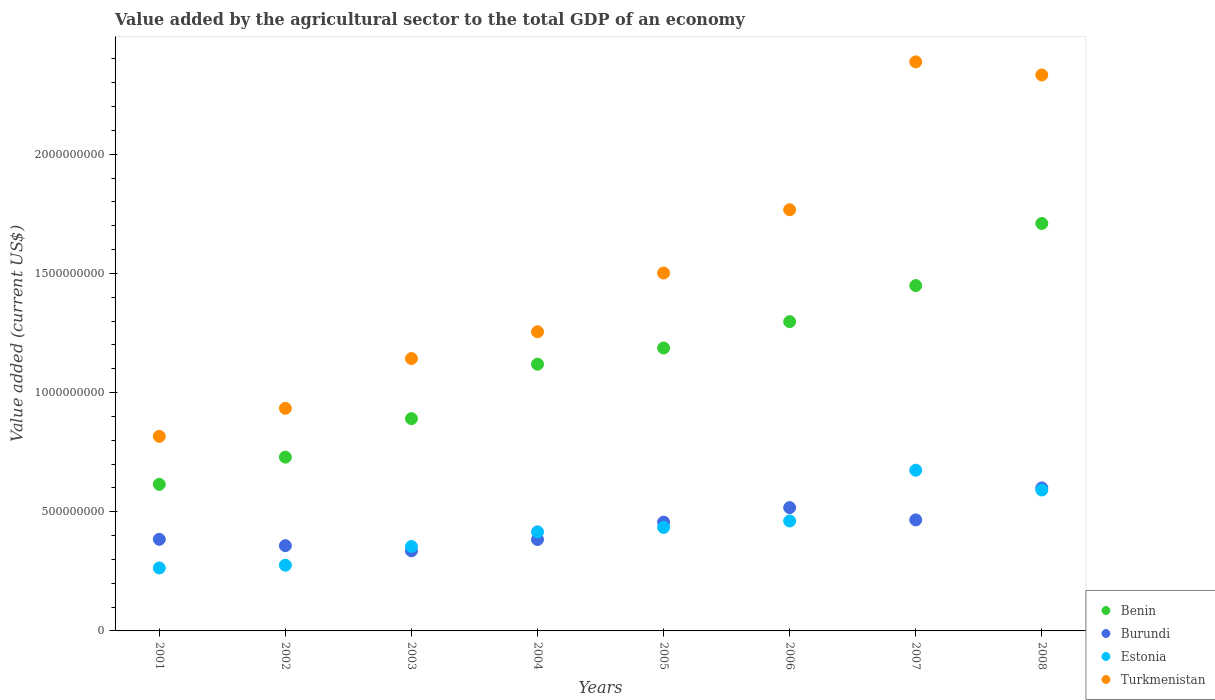Is the number of dotlines equal to the number of legend labels?
Offer a terse response. Yes. What is the value added by the agricultural sector to the total GDP in Turkmenistan in 2005?
Offer a terse response. 1.50e+09. Across all years, what is the maximum value added by the agricultural sector to the total GDP in Benin?
Keep it short and to the point. 1.71e+09. Across all years, what is the minimum value added by the agricultural sector to the total GDP in Benin?
Make the answer very short. 6.15e+08. In which year was the value added by the agricultural sector to the total GDP in Burundi minimum?
Ensure brevity in your answer.  2003. What is the total value added by the agricultural sector to the total GDP in Burundi in the graph?
Ensure brevity in your answer.  3.50e+09. What is the difference between the value added by the agricultural sector to the total GDP in Turkmenistan in 2002 and that in 2005?
Keep it short and to the point. -5.68e+08. What is the difference between the value added by the agricultural sector to the total GDP in Estonia in 2006 and the value added by the agricultural sector to the total GDP in Burundi in 2005?
Your answer should be compact. 4.91e+06. What is the average value added by the agricultural sector to the total GDP in Burundi per year?
Make the answer very short. 4.38e+08. In the year 2007, what is the difference between the value added by the agricultural sector to the total GDP in Turkmenistan and value added by the agricultural sector to the total GDP in Estonia?
Offer a very short reply. 1.71e+09. In how many years, is the value added by the agricultural sector to the total GDP in Turkmenistan greater than 2300000000 US$?
Your answer should be very brief. 2. What is the ratio of the value added by the agricultural sector to the total GDP in Benin in 2006 to that in 2007?
Provide a short and direct response. 0.9. Is the value added by the agricultural sector to the total GDP in Burundi in 2006 less than that in 2008?
Your answer should be very brief. Yes. Is the difference between the value added by the agricultural sector to the total GDP in Turkmenistan in 2005 and 2008 greater than the difference between the value added by the agricultural sector to the total GDP in Estonia in 2005 and 2008?
Offer a very short reply. No. What is the difference between the highest and the second highest value added by the agricultural sector to the total GDP in Benin?
Your answer should be compact. 2.61e+08. What is the difference between the highest and the lowest value added by the agricultural sector to the total GDP in Benin?
Your answer should be compact. 1.09e+09. In how many years, is the value added by the agricultural sector to the total GDP in Burundi greater than the average value added by the agricultural sector to the total GDP in Burundi taken over all years?
Your response must be concise. 4. Is the sum of the value added by the agricultural sector to the total GDP in Turkmenistan in 2001 and 2002 greater than the maximum value added by the agricultural sector to the total GDP in Benin across all years?
Provide a succinct answer. Yes. Is it the case that in every year, the sum of the value added by the agricultural sector to the total GDP in Estonia and value added by the agricultural sector to the total GDP in Benin  is greater than the sum of value added by the agricultural sector to the total GDP in Turkmenistan and value added by the agricultural sector to the total GDP in Burundi?
Ensure brevity in your answer.  No. Is the value added by the agricultural sector to the total GDP in Benin strictly less than the value added by the agricultural sector to the total GDP in Turkmenistan over the years?
Offer a very short reply. Yes. How many dotlines are there?
Your response must be concise. 4. How many years are there in the graph?
Give a very brief answer. 8. What is the difference between two consecutive major ticks on the Y-axis?
Make the answer very short. 5.00e+08. Are the values on the major ticks of Y-axis written in scientific E-notation?
Your answer should be compact. No. Does the graph contain any zero values?
Provide a short and direct response. No. How many legend labels are there?
Offer a very short reply. 4. How are the legend labels stacked?
Your answer should be very brief. Vertical. What is the title of the graph?
Ensure brevity in your answer.  Value added by the agricultural sector to the total GDP of an economy. Does "Denmark" appear as one of the legend labels in the graph?
Make the answer very short. No. What is the label or title of the Y-axis?
Make the answer very short. Value added (current US$). What is the Value added (current US$) in Benin in 2001?
Your answer should be compact. 6.15e+08. What is the Value added (current US$) in Burundi in 2001?
Your response must be concise. 3.84e+08. What is the Value added (current US$) in Estonia in 2001?
Provide a short and direct response. 2.64e+08. What is the Value added (current US$) in Turkmenistan in 2001?
Provide a succinct answer. 8.16e+08. What is the Value added (current US$) in Benin in 2002?
Offer a terse response. 7.29e+08. What is the Value added (current US$) in Burundi in 2002?
Provide a short and direct response. 3.58e+08. What is the Value added (current US$) in Estonia in 2002?
Offer a very short reply. 2.76e+08. What is the Value added (current US$) of Turkmenistan in 2002?
Offer a very short reply. 9.34e+08. What is the Value added (current US$) of Benin in 2003?
Your response must be concise. 8.91e+08. What is the Value added (current US$) of Burundi in 2003?
Provide a succinct answer. 3.36e+08. What is the Value added (current US$) in Estonia in 2003?
Your answer should be compact. 3.54e+08. What is the Value added (current US$) of Turkmenistan in 2003?
Give a very brief answer. 1.14e+09. What is the Value added (current US$) of Benin in 2004?
Offer a very short reply. 1.12e+09. What is the Value added (current US$) of Burundi in 2004?
Provide a succinct answer. 3.84e+08. What is the Value added (current US$) of Estonia in 2004?
Your answer should be compact. 4.16e+08. What is the Value added (current US$) in Turkmenistan in 2004?
Make the answer very short. 1.26e+09. What is the Value added (current US$) in Benin in 2005?
Offer a very short reply. 1.19e+09. What is the Value added (current US$) in Burundi in 2005?
Your answer should be very brief. 4.56e+08. What is the Value added (current US$) of Estonia in 2005?
Make the answer very short. 4.34e+08. What is the Value added (current US$) in Turkmenistan in 2005?
Ensure brevity in your answer.  1.50e+09. What is the Value added (current US$) of Benin in 2006?
Your answer should be very brief. 1.30e+09. What is the Value added (current US$) in Burundi in 2006?
Offer a terse response. 5.17e+08. What is the Value added (current US$) of Estonia in 2006?
Make the answer very short. 4.61e+08. What is the Value added (current US$) in Turkmenistan in 2006?
Give a very brief answer. 1.77e+09. What is the Value added (current US$) of Benin in 2007?
Ensure brevity in your answer.  1.45e+09. What is the Value added (current US$) of Burundi in 2007?
Keep it short and to the point. 4.66e+08. What is the Value added (current US$) of Estonia in 2007?
Offer a very short reply. 6.74e+08. What is the Value added (current US$) in Turkmenistan in 2007?
Provide a short and direct response. 2.39e+09. What is the Value added (current US$) of Benin in 2008?
Provide a succinct answer. 1.71e+09. What is the Value added (current US$) of Burundi in 2008?
Your answer should be very brief. 6.00e+08. What is the Value added (current US$) of Estonia in 2008?
Your response must be concise. 5.91e+08. What is the Value added (current US$) of Turkmenistan in 2008?
Offer a terse response. 2.33e+09. Across all years, what is the maximum Value added (current US$) of Benin?
Offer a very short reply. 1.71e+09. Across all years, what is the maximum Value added (current US$) of Burundi?
Provide a succinct answer. 6.00e+08. Across all years, what is the maximum Value added (current US$) in Estonia?
Provide a succinct answer. 6.74e+08. Across all years, what is the maximum Value added (current US$) of Turkmenistan?
Offer a very short reply. 2.39e+09. Across all years, what is the minimum Value added (current US$) in Benin?
Your response must be concise. 6.15e+08. Across all years, what is the minimum Value added (current US$) in Burundi?
Provide a succinct answer. 3.36e+08. Across all years, what is the minimum Value added (current US$) of Estonia?
Ensure brevity in your answer.  2.64e+08. Across all years, what is the minimum Value added (current US$) in Turkmenistan?
Offer a very short reply. 8.16e+08. What is the total Value added (current US$) of Benin in the graph?
Make the answer very short. 9.00e+09. What is the total Value added (current US$) in Burundi in the graph?
Your response must be concise. 3.50e+09. What is the total Value added (current US$) of Estonia in the graph?
Keep it short and to the point. 3.47e+09. What is the total Value added (current US$) in Turkmenistan in the graph?
Keep it short and to the point. 1.21e+1. What is the difference between the Value added (current US$) of Benin in 2001 and that in 2002?
Provide a short and direct response. -1.14e+08. What is the difference between the Value added (current US$) in Burundi in 2001 and that in 2002?
Keep it short and to the point. 2.67e+07. What is the difference between the Value added (current US$) of Estonia in 2001 and that in 2002?
Keep it short and to the point. -1.17e+07. What is the difference between the Value added (current US$) of Turkmenistan in 2001 and that in 2002?
Your answer should be compact. -1.18e+08. What is the difference between the Value added (current US$) of Benin in 2001 and that in 2003?
Make the answer very short. -2.76e+08. What is the difference between the Value added (current US$) in Burundi in 2001 and that in 2003?
Your answer should be compact. 4.83e+07. What is the difference between the Value added (current US$) in Estonia in 2001 and that in 2003?
Offer a terse response. -9.02e+07. What is the difference between the Value added (current US$) of Turkmenistan in 2001 and that in 2003?
Provide a succinct answer. -3.26e+08. What is the difference between the Value added (current US$) in Benin in 2001 and that in 2004?
Your answer should be very brief. -5.04e+08. What is the difference between the Value added (current US$) of Burundi in 2001 and that in 2004?
Offer a very short reply. 8.98e+05. What is the difference between the Value added (current US$) of Estonia in 2001 and that in 2004?
Keep it short and to the point. -1.52e+08. What is the difference between the Value added (current US$) in Turkmenistan in 2001 and that in 2004?
Give a very brief answer. -4.39e+08. What is the difference between the Value added (current US$) of Benin in 2001 and that in 2005?
Your response must be concise. -5.72e+08. What is the difference between the Value added (current US$) in Burundi in 2001 and that in 2005?
Your answer should be compact. -7.20e+07. What is the difference between the Value added (current US$) in Estonia in 2001 and that in 2005?
Keep it short and to the point. -1.70e+08. What is the difference between the Value added (current US$) of Turkmenistan in 2001 and that in 2005?
Offer a very short reply. -6.85e+08. What is the difference between the Value added (current US$) of Benin in 2001 and that in 2006?
Your response must be concise. -6.83e+08. What is the difference between the Value added (current US$) in Burundi in 2001 and that in 2006?
Ensure brevity in your answer.  -1.33e+08. What is the difference between the Value added (current US$) in Estonia in 2001 and that in 2006?
Ensure brevity in your answer.  -1.97e+08. What is the difference between the Value added (current US$) in Turkmenistan in 2001 and that in 2006?
Give a very brief answer. -9.51e+08. What is the difference between the Value added (current US$) of Benin in 2001 and that in 2007?
Offer a very short reply. -8.34e+08. What is the difference between the Value added (current US$) of Burundi in 2001 and that in 2007?
Your answer should be very brief. -8.14e+07. What is the difference between the Value added (current US$) in Estonia in 2001 and that in 2007?
Provide a short and direct response. -4.10e+08. What is the difference between the Value added (current US$) in Turkmenistan in 2001 and that in 2007?
Your answer should be compact. -1.57e+09. What is the difference between the Value added (current US$) of Benin in 2001 and that in 2008?
Your answer should be compact. -1.09e+09. What is the difference between the Value added (current US$) of Burundi in 2001 and that in 2008?
Offer a very short reply. -2.16e+08. What is the difference between the Value added (current US$) in Estonia in 2001 and that in 2008?
Provide a short and direct response. -3.27e+08. What is the difference between the Value added (current US$) in Turkmenistan in 2001 and that in 2008?
Provide a succinct answer. -1.52e+09. What is the difference between the Value added (current US$) of Benin in 2002 and that in 2003?
Offer a very short reply. -1.62e+08. What is the difference between the Value added (current US$) of Burundi in 2002 and that in 2003?
Give a very brief answer. 2.15e+07. What is the difference between the Value added (current US$) of Estonia in 2002 and that in 2003?
Your answer should be very brief. -7.86e+07. What is the difference between the Value added (current US$) of Turkmenistan in 2002 and that in 2003?
Your answer should be compact. -2.09e+08. What is the difference between the Value added (current US$) in Benin in 2002 and that in 2004?
Give a very brief answer. -3.90e+08. What is the difference between the Value added (current US$) in Burundi in 2002 and that in 2004?
Your answer should be very brief. -2.58e+07. What is the difference between the Value added (current US$) of Estonia in 2002 and that in 2004?
Make the answer very short. -1.40e+08. What is the difference between the Value added (current US$) of Turkmenistan in 2002 and that in 2004?
Your answer should be compact. -3.21e+08. What is the difference between the Value added (current US$) in Benin in 2002 and that in 2005?
Offer a very short reply. -4.58e+08. What is the difference between the Value added (current US$) in Burundi in 2002 and that in 2005?
Your answer should be very brief. -9.87e+07. What is the difference between the Value added (current US$) of Estonia in 2002 and that in 2005?
Offer a very short reply. -1.58e+08. What is the difference between the Value added (current US$) in Turkmenistan in 2002 and that in 2005?
Provide a succinct answer. -5.68e+08. What is the difference between the Value added (current US$) in Benin in 2002 and that in 2006?
Your answer should be very brief. -5.69e+08. What is the difference between the Value added (current US$) in Burundi in 2002 and that in 2006?
Ensure brevity in your answer.  -1.60e+08. What is the difference between the Value added (current US$) in Estonia in 2002 and that in 2006?
Your response must be concise. -1.86e+08. What is the difference between the Value added (current US$) of Turkmenistan in 2002 and that in 2006?
Provide a short and direct response. -8.33e+08. What is the difference between the Value added (current US$) of Benin in 2002 and that in 2007?
Offer a very short reply. -7.20e+08. What is the difference between the Value added (current US$) in Burundi in 2002 and that in 2007?
Offer a very short reply. -1.08e+08. What is the difference between the Value added (current US$) of Estonia in 2002 and that in 2007?
Provide a succinct answer. -3.99e+08. What is the difference between the Value added (current US$) in Turkmenistan in 2002 and that in 2007?
Ensure brevity in your answer.  -1.45e+09. What is the difference between the Value added (current US$) in Benin in 2002 and that in 2008?
Give a very brief answer. -9.81e+08. What is the difference between the Value added (current US$) of Burundi in 2002 and that in 2008?
Your answer should be compact. -2.42e+08. What is the difference between the Value added (current US$) of Estonia in 2002 and that in 2008?
Offer a terse response. -3.16e+08. What is the difference between the Value added (current US$) of Turkmenistan in 2002 and that in 2008?
Offer a terse response. -1.40e+09. What is the difference between the Value added (current US$) of Benin in 2003 and that in 2004?
Your response must be concise. -2.29e+08. What is the difference between the Value added (current US$) of Burundi in 2003 and that in 2004?
Offer a terse response. -4.74e+07. What is the difference between the Value added (current US$) of Estonia in 2003 and that in 2004?
Ensure brevity in your answer.  -6.14e+07. What is the difference between the Value added (current US$) in Turkmenistan in 2003 and that in 2004?
Make the answer very short. -1.12e+08. What is the difference between the Value added (current US$) of Benin in 2003 and that in 2005?
Your answer should be compact. -2.96e+08. What is the difference between the Value added (current US$) of Burundi in 2003 and that in 2005?
Make the answer very short. -1.20e+08. What is the difference between the Value added (current US$) of Estonia in 2003 and that in 2005?
Offer a very short reply. -7.99e+07. What is the difference between the Value added (current US$) in Turkmenistan in 2003 and that in 2005?
Ensure brevity in your answer.  -3.59e+08. What is the difference between the Value added (current US$) in Benin in 2003 and that in 2006?
Ensure brevity in your answer.  -4.07e+08. What is the difference between the Value added (current US$) in Burundi in 2003 and that in 2006?
Make the answer very short. -1.81e+08. What is the difference between the Value added (current US$) in Estonia in 2003 and that in 2006?
Give a very brief answer. -1.07e+08. What is the difference between the Value added (current US$) of Turkmenistan in 2003 and that in 2006?
Make the answer very short. -6.25e+08. What is the difference between the Value added (current US$) of Benin in 2003 and that in 2007?
Ensure brevity in your answer.  -5.58e+08. What is the difference between the Value added (current US$) of Burundi in 2003 and that in 2007?
Provide a succinct answer. -1.30e+08. What is the difference between the Value added (current US$) in Estonia in 2003 and that in 2007?
Provide a succinct answer. -3.20e+08. What is the difference between the Value added (current US$) of Turkmenistan in 2003 and that in 2007?
Your response must be concise. -1.24e+09. What is the difference between the Value added (current US$) of Benin in 2003 and that in 2008?
Give a very brief answer. -8.19e+08. What is the difference between the Value added (current US$) of Burundi in 2003 and that in 2008?
Your answer should be compact. -2.64e+08. What is the difference between the Value added (current US$) in Estonia in 2003 and that in 2008?
Keep it short and to the point. -2.37e+08. What is the difference between the Value added (current US$) of Turkmenistan in 2003 and that in 2008?
Make the answer very short. -1.19e+09. What is the difference between the Value added (current US$) in Benin in 2004 and that in 2005?
Give a very brief answer. -6.79e+07. What is the difference between the Value added (current US$) of Burundi in 2004 and that in 2005?
Make the answer very short. -7.29e+07. What is the difference between the Value added (current US$) of Estonia in 2004 and that in 2005?
Offer a terse response. -1.85e+07. What is the difference between the Value added (current US$) of Turkmenistan in 2004 and that in 2005?
Keep it short and to the point. -2.47e+08. What is the difference between the Value added (current US$) of Benin in 2004 and that in 2006?
Your answer should be compact. -1.79e+08. What is the difference between the Value added (current US$) of Burundi in 2004 and that in 2006?
Provide a succinct answer. -1.34e+08. What is the difference between the Value added (current US$) in Estonia in 2004 and that in 2006?
Give a very brief answer. -4.56e+07. What is the difference between the Value added (current US$) of Turkmenistan in 2004 and that in 2006?
Provide a succinct answer. -5.12e+08. What is the difference between the Value added (current US$) in Benin in 2004 and that in 2007?
Keep it short and to the point. -3.30e+08. What is the difference between the Value added (current US$) of Burundi in 2004 and that in 2007?
Your answer should be compact. -8.23e+07. What is the difference between the Value added (current US$) in Estonia in 2004 and that in 2007?
Keep it short and to the point. -2.59e+08. What is the difference between the Value added (current US$) of Turkmenistan in 2004 and that in 2007?
Ensure brevity in your answer.  -1.13e+09. What is the difference between the Value added (current US$) of Benin in 2004 and that in 2008?
Keep it short and to the point. -5.90e+08. What is the difference between the Value added (current US$) of Burundi in 2004 and that in 2008?
Your response must be concise. -2.17e+08. What is the difference between the Value added (current US$) of Estonia in 2004 and that in 2008?
Make the answer very short. -1.76e+08. What is the difference between the Value added (current US$) in Turkmenistan in 2004 and that in 2008?
Provide a succinct answer. -1.08e+09. What is the difference between the Value added (current US$) of Benin in 2005 and that in 2006?
Provide a succinct answer. -1.11e+08. What is the difference between the Value added (current US$) in Burundi in 2005 and that in 2006?
Provide a short and direct response. -6.11e+07. What is the difference between the Value added (current US$) in Estonia in 2005 and that in 2006?
Your response must be concise. -2.70e+07. What is the difference between the Value added (current US$) of Turkmenistan in 2005 and that in 2006?
Ensure brevity in your answer.  -2.66e+08. What is the difference between the Value added (current US$) of Benin in 2005 and that in 2007?
Provide a succinct answer. -2.62e+08. What is the difference between the Value added (current US$) of Burundi in 2005 and that in 2007?
Your response must be concise. -9.49e+06. What is the difference between the Value added (current US$) of Estonia in 2005 and that in 2007?
Give a very brief answer. -2.40e+08. What is the difference between the Value added (current US$) of Turkmenistan in 2005 and that in 2007?
Provide a short and direct response. -8.86e+08. What is the difference between the Value added (current US$) of Benin in 2005 and that in 2008?
Offer a very short reply. -5.22e+08. What is the difference between the Value added (current US$) in Burundi in 2005 and that in 2008?
Offer a very short reply. -1.44e+08. What is the difference between the Value added (current US$) in Estonia in 2005 and that in 2008?
Offer a very short reply. -1.57e+08. What is the difference between the Value added (current US$) of Turkmenistan in 2005 and that in 2008?
Your answer should be very brief. -8.31e+08. What is the difference between the Value added (current US$) in Benin in 2006 and that in 2007?
Give a very brief answer. -1.51e+08. What is the difference between the Value added (current US$) in Burundi in 2006 and that in 2007?
Your response must be concise. 5.16e+07. What is the difference between the Value added (current US$) in Estonia in 2006 and that in 2007?
Give a very brief answer. -2.13e+08. What is the difference between the Value added (current US$) in Turkmenistan in 2006 and that in 2007?
Your answer should be compact. -6.20e+08. What is the difference between the Value added (current US$) of Benin in 2006 and that in 2008?
Your answer should be compact. -4.12e+08. What is the difference between the Value added (current US$) in Burundi in 2006 and that in 2008?
Your answer should be compact. -8.27e+07. What is the difference between the Value added (current US$) in Estonia in 2006 and that in 2008?
Provide a succinct answer. -1.30e+08. What is the difference between the Value added (current US$) of Turkmenistan in 2006 and that in 2008?
Offer a terse response. -5.66e+08. What is the difference between the Value added (current US$) of Benin in 2007 and that in 2008?
Offer a terse response. -2.61e+08. What is the difference between the Value added (current US$) of Burundi in 2007 and that in 2008?
Offer a very short reply. -1.34e+08. What is the difference between the Value added (current US$) in Estonia in 2007 and that in 2008?
Your answer should be very brief. 8.30e+07. What is the difference between the Value added (current US$) in Turkmenistan in 2007 and that in 2008?
Provide a succinct answer. 5.48e+07. What is the difference between the Value added (current US$) in Benin in 2001 and the Value added (current US$) in Burundi in 2002?
Offer a terse response. 2.57e+08. What is the difference between the Value added (current US$) of Benin in 2001 and the Value added (current US$) of Estonia in 2002?
Ensure brevity in your answer.  3.39e+08. What is the difference between the Value added (current US$) in Benin in 2001 and the Value added (current US$) in Turkmenistan in 2002?
Your response must be concise. -3.19e+08. What is the difference between the Value added (current US$) in Burundi in 2001 and the Value added (current US$) in Estonia in 2002?
Offer a very short reply. 1.09e+08. What is the difference between the Value added (current US$) in Burundi in 2001 and the Value added (current US$) in Turkmenistan in 2002?
Offer a terse response. -5.50e+08. What is the difference between the Value added (current US$) in Estonia in 2001 and the Value added (current US$) in Turkmenistan in 2002?
Provide a succinct answer. -6.70e+08. What is the difference between the Value added (current US$) in Benin in 2001 and the Value added (current US$) in Burundi in 2003?
Make the answer very short. 2.79e+08. What is the difference between the Value added (current US$) in Benin in 2001 and the Value added (current US$) in Estonia in 2003?
Your response must be concise. 2.61e+08. What is the difference between the Value added (current US$) in Benin in 2001 and the Value added (current US$) in Turkmenistan in 2003?
Your response must be concise. -5.28e+08. What is the difference between the Value added (current US$) in Burundi in 2001 and the Value added (current US$) in Estonia in 2003?
Your response must be concise. 3.00e+07. What is the difference between the Value added (current US$) of Burundi in 2001 and the Value added (current US$) of Turkmenistan in 2003?
Give a very brief answer. -7.58e+08. What is the difference between the Value added (current US$) in Estonia in 2001 and the Value added (current US$) in Turkmenistan in 2003?
Your answer should be compact. -8.79e+08. What is the difference between the Value added (current US$) of Benin in 2001 and the Value added (current US$) of Burundi in 2004?
Your response must be concise. 2.32e+08. What is the difference between the Value added (current US$) in Benin in 2001 and the Value added (current US$) in Estonia in 2004?
Make the answer very short. 1.99e+08. What is the difference between the Value added (current US$) of Benin in 2001 and the Value added (current US$) of Turkmenistan in 2004?
Keep it short and to the point. -6.40e+08. What is the difference between the Value added (current US$) in Burundi in 2001 and the Value added (current US$) in Estonia in 2004?
Offer a terse response. -3.13e+07. What is the difference between the Value added (current US$) of Burundi in 2001 and the Value added (current US$) of Turkmenistan in 2004?
Your answer should be compact. -8.71e+08. What is the difference between the Value added (current US$) of Estonia in 2001 and the Value added (current US$) of Turkmenistan in 2004?
Ensure brevity in your answer.  -9.91e+08. What is the difference between the Value added (current US$) in Benin in 2001 and the Value added (current US$) in Burundi in 2005?
Ensure brevity in your answer.  1.59e+08. What is the difference between the Value added (current US$) in Benin in 2001 and the Value added (current US$) in Estonia in 2005?
Offer a very short reply. 1.81e+08. What is the difference between the Value added (current US$) of Benin in 2001 and the Value added (current US$) of Turkmenistan in 2005?
Ensure brevity in your answer.  -8.87e+08. What is the difference between the Value added (current US$) in Burundi in 2001 and the Value added (current US$) in Estonia in 2005?
Your answer should be very brief. -4.98e+07. What is the difference between the Value added (current US$) of Burundi in 2001 and the Value added (current US$) of Turkmenistan in 2005?
Provide a short and direct response. -1.12e+09. What is the difference between the Value added (current US$) in Estonia in 2001 and the Value added (current US$) in Turkmenistan in 2005?
Your answer should be compact. -1.24e+09. What is the difference between the Value added (current US$) of Benin in 2001 and the Value added (current US$) of Burundi in 2006?
Offer a very short reply. 9.77e+07. What is the difference between the Value added (current US$) in Benin in 2001 and the Value added (current US$) in Estonia in 2006?
Provide a short and direct response. 1.54e+08. What is the difference between the Value added (current US$) of Benin in 2001 and the Value added (current US$) of Turkmenistan in 2006?
Give a very brief answer. -1.15e+09. What is the difference between the Value added (current US$) of Burundi in 2001 and the Value added (current US$) of Estonia in 2006?
Offer a terse response. -7.69e+07. What is the difference between the Value added (current US$) in Burundi in 2001 and the Value added (current US$) in Turkmenistan in 2006?
Make the answer very short. -1.38e+09. What is the difference between the Value added (current US$) in Estonia in 2001 and the Value added (current US$) in Turkmenistan in 2006?
Offer a very short reply. -1.50e+09. What is the difference between the Value added (current US$) in Benin in 2001 and the Value added (current US$) in Burundi in 2007?
Offer a very short reply. 1.49e+08. What is the difference between the Value added (current US$) of Benin in 2001 and the Value added (current US$) of Estonia in 2007?
Provide a succinct answer. -5.92e+07. What is the difference between the Value added (current US$) in Benin in 2001 and the Value added (current US$) in Turkmenistan in 2007?
Your answer should be very brief. -1.77e+09. What is the difference between the Value added (current US$) in Burundi in 2001 and the Value added (current US$) in Estonia in 2007?
Keep it short and to the point. -2.90e+08. What is the difference between the Value added (current US$) in Burundi in 2001 and the Value added (current US$) in Turkmenistan in 2007?
Provide a succinct answer. -2.00e+09. What is the difference between the Value added (current US$) in Estonia in 2001 and the Value added (current US$) in Turkmenistan in 2007?
Provide a succinct answer. -2.12e+09. What is the difference between the Value added (current US$) in Benin in 2001 and the Value added (current US$) in Burundi in 2008?
Your response must be concise. 1.50e+07. What is the difference between the Value added (current US$) in Benin in 2001 and the Value added (current US$) in Estonia in 2008?
Provide a succinct answer. 2.37e+07. What is the difference between the Value added (current US$) in Benin in 2001 and the Value added (current US$) in Turkmenistan in 2008?
Make the answer very short. -1.72e+09. What is the difference between the Value added (current US$) of Burundi in 2001 and the Value added (current US$) of Estonia in 2008?
Your answer should be very brief. -2.07e+08. What is the difference between the Value added (current US$) of Burundi in 2001 and the Value added (current US$) of Turkmenistan in 2008?
Provide a succinct answer. -1.95e+09. What is the difference between the Value added (current US$) in Estonia in 2001 and the Value added (current US$) in Turkmenistan in 2008?
Your answer should be compact. -2.07e+09. What is the difference between the Value added (current US$) of Benin in 2002 and the Value added (current US$) of Burundi in 2003?
Your response must be concise. 3.93e+08. What is the difference between the Value added (current US$) in Benin in 2002 and the Value added (current US$) in Estonia in 2003?
Provide a short and direct response. 3.75e+08. What is the difference between the Value added (current US$) of Benin in 2002 and the Value added (current US$) of Turkmenistan in 2003?
Your response must be concise. -4.14e+08. What is the difference between the Value added (current US$) in Burundi in 2002 and the Value added (current US$) in Estonia in 2003?
Ensure brevity in your answer.  3.30e+06. What is the difference between the Value added (current US$) of Burundi in 2002 and the Value added (current US$) of Turkmenistan in 2003?
Your answer should be compact. -7.85e+08. What is the difference between the Value added (current US$) of Estonia in 2002 and the Value added (current US$) of Turkmenistan in 2003?
Your answer should be very brief. -8.67e+08. What is the difference between the Value added (current US$) in Benin in 2002 and the Value added (current US$) in Burundi in 2004?
Provide a short and direct response. 3.46e+08. What is the difference between the Value added (current US$) in Benin in 2002 and the Value added (current US$) in Estonia in 2004?
Your response must be concise. 3.13e+08. What is the difference between the Value added (current US$) in Benin in 2002 and the Value added (current US$) in Turkmenistan in 2004?
Offer a terse response. -5.26e+08. What is the difference between the Value added (current US$) in Burundi in 2002 and the Value added (current US$) in Estonia in 2004?
Your response must be concise. -5.81e+07. What is the difference between the Value added (current US$) in Burundi in 2002 and the Value added (current US$) in Turkmenistan in 2004?
Your response must be concise. -8.98e+08. What is the difference between the Value added (current US$) in Estonia in 2002 and the Value added (current US$) in Turkmenistan in 2004?
Your answer should be compact. -9.79e+08. What is the difference between the Value added (current US$) of Benin in 2002 and the Value added (current US$) of Burundi in 2005?
Keep it short and to the point. 2.73e+08. What is the difference between the Value added (current US$) of Benin in 2002 and the Value added (current US$) of Estonia in 2005?
Ensure brevity in your answer.  2.95e+08. What is the difference between the Value added (current US$) of Benin in 2002 and the Value added (current US$) of Turkmenistan in 2005?
Offer a very short reply. -7.73e+08. What is the difference between the Value added (current US$) in Burundi in 2002 and the Value added (current US$) in Estonia in 2005?
Offer a very short reply. -7.66e+07. What is the difference between the Value added (current US$) in Burundi in 2002 and the Value added (current US$) in Turkmenistan in 2005?
Make the answer very short. -1.14e+09. What is the difference between the Value added (current US$) of Estonia in 2002 and the Value added (current US$) of Turkmenistan in 2005?
Give a very brief answer. -1.23e+09. What is the difference between the Value added (current US$) of Benin in 2002 and the Value added (current US$) of Burundi in 2006?
Give a very brief answer. 2.12e+08. What is the difference between the Value added (current US$) of Benin in 2002 and the Value added (current US$) of Estonia in 2006?
Your answer should be compact. 2.68e+08. What is the difference between the Value added (current US$) in Benin in 2002 and the Value added (current US$) in Turkmenistan in 2006?
Keep it short and to the point. -1.04e+09. What is the difference between the Value added (current US$) of Burundi in 2002 and the Value added (current US$) of Estonia in 2006?
Your response must be concise. -1.04e+08. What is the difference between the Value added (current US$) in Burundi in 2002 and the Value added (current US$) in Turkmenistan in 2006?
Keep it short and to the point. -1.41e+09. What is the difference between the Value added (current US$) in Estonia in 2002 and the Value added (current US$) in Turkmenistan in 2006?
Keep it short and to the point. -1.49e+09. What is the difference between the Value added (current US$) of Benin in 2002 and the Value added (current US$) of Burundi in 2007?
Make the answer very short. 2.63e+08. What is the difference between the Value added (current US$) in Benin in 2002 and the Value added (current US$) in Estonia in 2007?
Ensure brevity in your answer.  5.48e+07. What is the difference between the Value added (current US$) of Benin in 2002 and the Value added (current US$) of Turkmenistan in 2007?
Your answer should be very brief. -1.66e+09. What is the difference between the Value added (current US$) of Burundi in 2002 and the Value added (current US$) of Estonia in 2007?
Keep it short and to the point. -3.17e+08. What is the difference between the Value added (current US$) of Burundi in 2002 and the Value added (current US$) of Turkmenistan in 2007?
Ensure brevity in your answer.  -2.03e+09. What is the difference between the Value added (current US$) of Estonia in 2002 and the Value added (current US$) of Turkmenistan in 2007?
Give a very brief answer. -2.11e+09. What is the difference between the Value added (current US$) of Benin in 2002 and the Value added (current US$) of Burundi in 2008?
Keep it short and to the point. 1.29e+08. What is the difference between the Value added (current US$) of Benin in 2002 and the Value added (current US$) of Estonia in 2008?
Ensure brevity in your answer.  1.38e+08. What is the difference between the Value added (current US$) in Benin in 2002 and the Value added (current US$) in Turkmenistan in 2008?
Provide a succinct answer. -1.60e+09. What is the difference between the Value added (current US$) of Burundi in 2002 and the Value added (current US$) of Estonia in 2008?
Provide a short and direct response. -2.34e+08. What is the difference between the Value added (current US$) in Burundi in 2002 and the Value added (current US$) in Turkmenistan in 2008?
Provide a succinct answer. -1.98e+09. What is the difference between the Value added (current US$) of Estonia in 2002 and the Value added (current US$) of Turkmenistan in 2008?
Offer a terse response. -2.06e+09. What is the difference between the Value added (current US$) in Benin in 2003 and the Value added (current US$) in Burundi in 2004?
Ensure brevity in your answer.  5.07e+08. What is the difference between the Value added (current US$) in Benin in 2003 and the Value added (current US$) in Estonia in 2004?
Provide a succinct answer. 4.75e+08. What is the difference between the Value added (current US$) of Benin in 2003 and the Value added (current US$) of Turkmenistan in 2004?
Provide a succinct answer. -3.64e+08. What is the difference between the Value added (current US$) in Burundi in 2003 and the Value added (current US$) in Estonia in 2004?
Give a very brief answer. -7.96e+07. What is the difference between the Value added (current US$) of Burundi in 2003 and the Value added (current US$) of Turkmenistan in 2004?
Your response must be concise. -9.19e+08. What is the difference between the Value added (current US$) in Estonia in 2003 and the Value added (current US$) in Turkmenistan in 2004?
Provide a succinct answer. -9.01e+08. What is the difference between the Value added (current US$) of Benin in 2003 and the Value added (current US$) of Burundi in 2005?
Make the answer very short. 4.34e+08. What is the difference between the Value added (current US$) in Benin in 2003 and the Value added (current US$) in Estonia in 2005?
Provide a short and direct response. 4.56e+08. What is the difference between the Value added (current US$) of Benin in 2003 and the Value added (current US$) of Turkmenistan in 2005?
Give a very brief answer. -6.11e+08. What is the difference between the Value added (current US$) in Burundi in 2003 and the Value added (current US$) in Estonia in 2005?
Offer a very short reply. -9.81e+07. What is the difference between the Value added (current US$) in Burundi in 2003 and the Value added (current US$) in Turkmenistan in 2005?
Your response must be concise. -1.17e+09. What is the difference between the Value added (current US$) in Estonia in 2003 and the Value added (current US$) in Turkmenistan in 2005?
Make the answer very short. -1.15e+09. What is the difference between the Value added (current US$) in Benin in 2003 and the Value added (current US$) in Burundi in 2006?
Offer a very short reply. 3.73e+08. What is the difference between the Value added (current US$) in Benin in 2003 and the Value added (current US$) in Estonia in 2006?
Your answer should be compact. 4.29e+08. What is the difference between the Value added (current US$) of Benin in 2003 and the Value added (current US$) of Turkmenistan in 2006?
Your answer should be compact. -8.77e+08. What is the difference between the Value added (current US$) in Burundi in 2003 and the Value added (current US$) in Estonia in 2006?
Provide a short and direct response. -1.25e+08. What is the difference between the Value added (current US$) in Burundi in 2003 and the Value added (current US$) in Turkmenistan in 2006?
Your answer should be compact. -1.43e+09. What is the difference between the Value added (current US$) of Estonia in 2003 and the Value added (current US$) of Turkmenistan in 2006?
Make the answer very short. -1.41e+09. What is the difference between the Value added (current US$) of Benin in 2003 and the Value added (current US$) of Burundi in 2007?
Offer a very short reply. 4.25e+08. What is the difference between the Value added (current US$) of Benin in 2003 and the Value added (current US$) of Estonia in 2007?
Offer a very short reply. 2.16e+08. What is the difference between the Value added (current US$) in Benin in 2003 and the Value added (current US$) in Turkmenistan in 2007?
Provide a succinct answer. -1.50e+09. What is the difference between the Value added (current US$) of Burundi in 2003 and the Value added (current US$) of Estonia in 2007?
Give a very brief answer. -3.38e+08. What is the difference between the Value added (current US$) of Burundi in 2003 and the Value added (current US$) of Turkmenistan in 2007?
Provide a succinct answer. -2.05e+09. What is the difference between the Value added (current US$) in Estonia in 2003 and the Value added (current US$) in Turkmenistan in 2007?
Provide a short and direct response. -2.03e+09. What is the difference between the Value added (current US$) in Benin in 2003 and the Value added (current US$) in Burundi in 2008?
Make the answer very short. 2.91e+08. What is the difference between the Value added (current US$) in Benin in 2003 and the Value added (current US$) in Estonia in 2008?
Give a very brief answer. 2.99e+08. What is the difference between the Value added (current US$) in Benin in 2003 and the Value added (current US$) in Turkmenistan in 2008?
Provide a succinct answer. -1.44e+09. What is the difference between the Value added (current US$) of Burundi in 2003 and the Value added (current US$) of Estonia in 2008?
Your answer should be very brief. -2.55e+08. What is the difference between the Value added (current US$) in Burundi in 2003 and the Value added (current US$) in Turkmenistan in 2008?
Keep it short and to the point. -2.00e+09. What is the difference between the Value added (current US$) in Estonia in 2003 and the Value added (current US$) in Turkmenistan in 2008?
Your answer should be very brief. -1.98e+09. What is the difference between the Value added (current US$) in Benin in 2004 and the Value added (current US$) in Burundi in 2005?
Your answer should be very brief. 6.63e+08. What is the difference between the Value added (current US$) of Benin in 2004 and the Value added (current US$) of Estonia in 2005?
Offer a very short reply. 6.85e+08. What is the difference between the Value added (current US$) of Benin in 2004 and the Value added (current US$) of Turkmenistan in 2005?
Give a very brief answer. -3.83e+08. What is the difference between the Value added (current US$) in Burundi in 2004 and the Value added (current US$) in Estonia in 2005?
Keep it short and to the point. -5.07e+07. What is the difference between the Value added (current US$) of Burundi in 2004 and the Value added (current US$) of Turkmenistan in 2005?
Provide a succinct answer. -1.12e+09. What is the difference between the Value added (current US$) of Estonia in 2004 and the Value added (current US$) of Turkmenistan in 2005?
Offer a terse response. -1.09e+09. What is the difference between the Value added (current US$) in Benin in 2004 and the Value added (current US$) in Burundi in 2006?
Keep it short and to the point. 6.02e+08. What is the difference between the Value added (current US$) in Benin in 2004 and the Value added (current US$) in Estonia in 2006?
Offer a very short reply. 6.58e+08. What is the difference between the Value added (current US$) in Benin in 2004 and the Value added (current US$) in Turkmenistan in 2006?
Ensure brevity in your answer.  -6.48e+08. What is the difference between the Value added (current US$) in Burundi in 2004 and the Value added (current US$) in Estonia in 2006?
Provide a short and direct response. -7.78e+07. What is the difference between the Value added (current US$) of Burundi in 2004 and the Value added (current US$) of Turkmenistan in 2006?
Your answer should be compact. -1.38e+09. What is the difference between the Value added (current US$) in Estonia in 2004 and the Value added (current US$) in Turkmenistan in 2006?
Provide a succinct answer. -1.35e+09. What is the difference between the Value added (current US$) of Benin in 2004 and the Value added (current US$) of Burundi in 2007?
Offer a very short reply. 6.53e+08. What is the difference between the Value added (current US$) of Benin in 2004 and the Value added (current US$) of Estonia in 2007?
Ensure brevity in your answer.  4.45e+08. What is the difference between the Value added (current US$) in Benin in 2004 and the Value added (current US$) in Turkmenistan in 2007?
Your response must be concise. -1.27e+09. What is the difference between the Value added (current US$) of Burundi in 2004 and the Value added (current US$) of Estonia in 2007?
Give a very brief answer. -2.91e+08. What is the difference between the Value added (current US$) of Burundi in 2004 and the Value added (current US$) of Turkmenistan in 2007?
Make the answer very short. -2.00e+09. What is the difference between the Value added (current US$) of Estonia in 2004 and the Value added (current US$) of Turkmenistan in 2007?
Your answer should be very brief. -1.97e+09. What is the difference between the Value added (current US$) in Benin in 2004 and the Value added (current US$) in Burundi in 2008?
Provide a succinct answer. 5.19e+08. What is the difference between the Value added (current US$) in Benin in 2004 and the Value added (current US$) in Estonia in 2008?
Provide a short and direct response. 5.28e+08. What is the difference between the Value added (current US$) of Benin in 2004 and the Value added (current US$) of Turkmenistan in 2008?
Provide a succinct answer. -1.21e+09. What is the difference between the Value added (current US$) in Burundi in 2004 and the Value added (current US$) in Estonia in 2008?
Give a very brief answer. -2.08e+08. What is the difference between the Value added (current US$) of Burundi in 2004 and the Value added (current US$) of Turkmenistan in 2008?
Give a very brief answer. -1.95e+09. What is the difference between the Value added (current US$) in Estonia in 2004 and the Value added (current US$) in Turkmenistan in 2008?
Ensure brevity in your answer.  -1.92e+09. What is the difference between the Value added (current US$) in Benin in 2005 and the Value added (current US$) in Burundi in 2006?
Provide a succinct answer. 6.70e+08. What is the difference between the Value added (current US$) in Benin in 2005 and the Value added (current US$) in Estonia in 2006?
Give a very brief answer. 7.26e+08. What is the difference between the Value added (current US$) in Benin in 2005 and the Value added (current US$) in Turkmenistan in 2006?
Keep it short and to the point. -5.80e+08. What is the difference between the Value added (current US$) in Burundi in 2005 and the Value added (current US$) in Estonia in 2006?
Your answer should be compact. -4.91e+06. What is the difference between the Value added (current US$) of Burundi in 2005 and the Value added (current US$) of Turkmenistan in 2006?
Ensure brevity in your answer.  -1.31e+09. What is the difference between the Value added (current US$) in Estonia in 2005 and the Value added (current US$) in Turkmenistan in 2006?
Offer a terse response. -1.33e+09. What is the difference between the Value added (current US$) in Benin in 2005 and the Value added (current US$) in Burundi in 2007?
Provide a succinct answer. 7.21e+08. What is the difference between the Value added (current US$) of Benin in 2005 and the Value added (current US$) of Estonia in 2007?
Ensure brevity in your answer.  5.13e+08. What is the difference between the Value added (current US$) of Benin in 2005 and the Value added (current US$) of Turkmenistan in 2007?
Offer a terse response. -1.20e+09. What is the difference between the Value added (current US$) in Burundi in 2005 and the Value added (current US$) in Estonia in 2007?
Ensure brevity in your answer.  -2.18e+08. What is the difference between the Value added (current US$) in Burundi in 2005 and the Value added (current US$) in Turkmenistan in 2007?
Make the answer very short. -1.93e+09. What is the difference between the Value added (current US$) of Estonia in 2005 and the Value added (current US$) of Turkmenistan in 2007?
Offer a terse response. -1.95e+09. What is the difference between the Value added (current US$) of Benin in 2005 and the Value added (current US$) of Burundi in 2008?
Provide a succinct answer. 5.87e+08. What is the difference between the Value added (current US$) of Benin in 2005 and the Value added (current US$) of Estonia in 2008?
Keep it short and to the point. 5.96e+08. What is the difference between the Value added (current US$) in Benin in 2005 and the Value added (current US$) in Turkmenistan in 2008?
Your response must be concise. -1.15e+09. What is the difference between the Value added (current US$) in Burundi in 2005 and the Value added (current US$) in Estonia in 2008?
Your answer should be compact. -1.35e+08. What is the difference between the Value added (current US$) in Burundi in 2005 and the Value added (current US$) in Turkmenistan in 2008?
Your response must be concise. -1.88e+09. What is the difference between the Value added (current US$) of Estonia in 2005 and the Value added (current US$) of Turkmenistan in 2008?
Make the answer very short. -1.90e+09. What is the difference between the Value added (current US$) in Benin in 2006 and the Value added (current US$) in Burundi in 2007?
Ensure brevity in your answer.  8.32e+08. What is the difference between the Value added (current US$) in Benin in 2006 and the Value added (current US$) in Estonia in 2007?
Provide a succinct answer. 6.23e+08. What is the difference between the Value added (current US$) in Benin in 2006 and the Value added (current US$) in Turkmenistan in 2007?
Offer a very short reply. -1.09e+09. What is the difference between the Value added (current US$) of Burundi in 2006 and the Value added (current US$) of Estonia in 2007?
Your response must be concise. -1.57e+08. What is the difference between the Value added (current US$) of Burundi in 2006 and the Value added (current US$) of Turkmenistan in 2007?
Offer a very short reply. -1.87e+09. What is the difference between the Value added (current US$) in Estonia in 2006 and the Value added (current US$) in Turkmenistan in 2007?
Ensure brevity in your answer.  -1.93e+09. What is the difference between the Value added (current US$) of Benin in 2006 and the Value added (current US$) of Burundi in 2008?
Offer a very short reply. 6.98e+08. What is the difference between the Value added (current US$) in Benin in 2006 and the Value added (current US$) in Estonia in 2008?
Ensure brevity in your answer.  7.06e+08. What is the difference between the Value added (current US$) of Benin in 2006 and the Value added (current US$) of Turkmenistan in 2008?
Make the answer very short. -1.04e+09. What is the difference between the Value added (current US$) of Burundi in 2006 and the Value added (current US$) of Estonia in 2008?
Offer a very short reply. -7.39e+07. What is the difference between the Value added (current US$) in Burundi in 2006 and the Value added (current US$) in Turkmenistan in 2008?
Offer a terse response. -1.82e+09. What is the difference between the Value added (current US$) of Estonia in 2006 and the Value added (current US$) of Turkmenistan in 2008?
Ensure brevity in your answer.  -1.87e+09. What is the difference between the Value added (current US$) in Benin in 2007 and the Value added (current US$) in Burundi in 2008?
Offer a very short reply. 8.49e+08. What is the difference between the Value added (current US$) in Benin in 2007 and the Value added (current US$) in Estonia in 2008?
Keep it short and to the point. 8.58e+08. What is the difference between the Value added (current US$) of Benin in 2007 and the Value added (current US$) of Turkmenistan in 2008?
Keep it short and to the point. -8.84e+08. What is the difference between the Value added (current US$) of Burundi in 2007 and the Value added (current US$) of Estonia in 2008?
Keep it short and to the point. -1.26e+08. What is the difference between the Value added (current US$) in Burundi in 2007 and the Value added (current US$) in Turkmenistan in 2008?
Ensure brevity in your answer.  -1.87e+09. What is the difference between the Value added (current US$) in Estonia in 2007 and the Value added (current US$) in Turkmenistan in 2008?
Your answer should be compact. -1.66e+09. What is the average Value added (current US$) of Benin per year?
Your answer should be very brief. 1.12e+09. What is the average Value added (current US$) in Burundi per year?
Ensure brevity in your answer.  4.38e+08. What is the average Value added (current US$) of Estonia per year?
Make the answer very short. 4.34e+08. What is the average Value added (current US$) of Turkmenistan per year?
Ensure brevity in your answer.  1.52e+09. In the year 2001, what is the difference between the Value added (current US$) of Benin and Value added (current US$) of Burundi?
Your response must be concise. 2.31e+08. In the year 2001, what is the difference between the Value added (current US$) of Benin and Value added (current US$) of Estonia?
Offer a very short reply. 3.51e+08. In the year 2001, what is the difference between the Value added (current US$) of Benin and Value added (current US$) of Turkmenistan?
Make the answer very short. -2.01e+08. In the year 2001, what is the difference between the Value added (current US$) in Burundi and Value added (current US$) in Estonia?
Provide a succinct answer. 1.20e+08. In the year 2001, what is the difference between the Value added (current US$) of Burundi and Value added (current US$) of Turkmenistan?
Make the answer very short. -4.32e+08. In the year 2001, what is the difference between the Value added (current US$) in Estonia and Value added (current US$) in Turkmenistan?
Your answer should be very brief. -5.52e+08. In the year 2002, what is the difference between the Value added (current US$) of Benin and Value added (current US$) of Burundi?
Make the answer very short. 3.71e+08. In the year 2002, what is the difference between the Value added (current US$) of Benin and Value added (current US$) of Estonia?
Give a very brief answer. 4.53e+08. In the year 2002, what is the difference between the Value added (current US$) of Benin and Value added (current US$) of Turkmenistan?
Make the answer very short. -2.05e+08. In the year 2002, what is the difference between the Value added (current US$) of Burundi and Value added (current US$) of Estonia?
Your response must be concise. 8.19e+07. In the year 2002, what is the difference between the Value added (current US$) in Burundi and Value added (current US$) in Turkmenistan?
Ensure brevity in your answer.  -5.76e+08. In the year 2002, what is the difference between the Value added (current US$) in Estonia and Value added (current US$) in Turkmenistan?
Keep it short and to the point. -6.58e+08. In the year 2003, what is the difference between the Value added (current US$) in Benin and Value added (current US$) in Burundi?
Give a very brief answer. 5.55e+08. In the year 2003, what is the difference between the Value added (current US$) of Benin and Value added (current US$) of Estonia?
Offer a terse response. 5.36e+08. In the year 2003, what is the difference between the Value added (current US$) of Benin and Value added (current US$) of Turkmenistan?
Give a very brief answer. -2.52e+08. In the year 2003, what is the difference between the Value added (current US$) of Burundi and Value added (current US$) of Estonia?
Make the answer very short. -1.82e+07. In the year 2003, what is the difference between the Value added (current US$) in Burundi and Value added (current US$) in Turkmenistan?
Make the answer very short. -8.07e+08. In the year 2003, what is the difference between the Value added (current US$) in Estonia and Value added (current US$) in Turkmenistan?
Give a very brief answer. -7.88e+08. In the year 2004, what is the difference between the Value added (current US$) in Benin and Value added (current US$) in Burundi?
Give a very brief answer. 7.36e+08. In the year 2004, what is the difference between the Value added (current US$) of Benin and Value added (current US$) of Estonia?
Offer a very short reply. 7.04e+08. In the year 2004, what is the difference between the Value added (current US$) in Benin and Value added (current US$) in Turkmenistan?
Offer a terse response. -1.36e+08. In the year 2004, what is the difference between the Value added (current US$) of Burundi and Value added (current US$) of Estonia?
Give a very brief answer. -3.22e+07. In the year 2004, what is the difference between the Value added (current US$) of Burundi and Value added (current US$) of Turkmenistan?
Ensure brevity in your answer.  -8.72e+08. In the year 2004, what is the difference between the Value added (current US$) of Estonia and Value added (current US$) of Turkmenistan?
Ensure brevity in your answer.  -8.39e+08. In the year 2005, what is the difference between the Value added (current US$) in Benin and Value added (current US$) in Burundi?
Ensure brevity in your answer.  7.31e+08. In the year 2005, what is the difference between the Value added (current US$) of Benin and Value added (current US$) of Estonia?
Your response must be concise. 7.53e+08. In the year 2005, what is the difference between the Value added (current US$) in Benin and Value added (current US$) in Turkmenistan?
Your answer should be compact. -3.15e+08. In the year 2005, what is the difference between the Value added (current US$) in Burundi and Value added (current US$) in Estonia?
Make the answer very short. 2.21e+07. In the year 2005, what is the difference between the Value added (current US$) in Burundi and Value added (current US$) in Turkmenistan?
Offer a very short reply. -1.05e+09. In the year 2005, what is the difference between the Value added (current US$) of Estonia and Value added (current US$) of Turkmenistan?
Keep it short and to the point. -1.07e+09. In the year 2006, what is the difference between the Value added (current US$) of Benin and Value added (current US$) of Burundi?
Your answer should be compact. 7.80e+08. In the year 2006, what is the difference between the Value added (current US$) of Benin and Value added (current US$) of Estonia?
Provide a succinct answer. 8.37e+08. In the year 2006, what is the difference between the Value added (current US$) of Benin and Value added (current US$) of Turkmenistan?
Give a very brief answer. -4.70e+08. In the year 2006, what is the difference between the Value added (current US$) of Burundi and Value added (current US$) of Estonia?
Your response must be concise. 5.62e+07. In the year 2006, what is the difference between the Value added (current US$) in Burundi and Value added (current US$) in Turkmenistan?
Give a very brief answer. -1.25e+09. In the year 2006, what is the difference between the Value added (current US$) in Estonia and Value added (current US$) in Turkmenistan?
Offer a very short reply. -1.31e+09. In the year 2007, what is the difference between the Value added (current US$) of Benin and Value added (current US$) of Burundi?
Your response must be concise. 9.83e+08. In the year 2007, what is the difference between the Value added (current US$) in Benin and Value added (current US$) in Estonia?
Keep it short and to the point. 7.75e+08. In the year 2007, what is the difference between the Value added (current US$) of Benin and Value added (current US$) of Turkmenistan?
Keep it short and to the point. -9.39e+08. In the year 2007, what is the difference between the Value added (current US$) in Burundi and Value added (current US$) in Estonia?
Keep it short and to the point. -2.08e+08. In the year 2007, what is the difference between the Value added (current US$) of Burundi and Value added (current US$) of Turkmenistan?
Your answer should be compact. -1.92e+09. In the year 2007, what is the difference between the Value added (current US$) in Estonia and Value added (current US$) in Turkmenistan?
Your answer should be compact. -1.71e+09. In the year 2008, what is the difference between the Value added (current US$) in Benin and Value added (current US$) in Burundi?
Your answer should be very brief. 1.11e+09. In the year 2008, what is the difference between the Value added (current US$) of Benin and Value added (current US$) of Estonia?
Provide a short and direct response. 1.12e+09. In the year 2008, what is the difference between the Value added (current US$) of Benin and Value added (current US$) of Turkmenistan?
Provide a short and direct response. -6.23e+08. In the year 2008, what is the difference between the Value added (current US$) in Burundi and Value added (current US$) in Estonia?
Provide a short and direct response. 8.78e+06. In the year 2008, what is the difference between the Value added (current US$) in Burundi and Value added (current US$) in Turkmenistan?
Provide a succinct answer. -1.73e+09. In the year 2008, what is the difference between the Value added (current US$) of Estonia and Value added (current US$) of Turkmenistan?
Your answer should be very brief. -1.74e+09. What is the ratio of the Value added (current US$) of Benin in 2001 to that in 2002?
Your response must be concise. 0.84. What is the ratio of the Value added (current US$) in Burundi in 2001 to that in 2002?
Make the answer very short. 1.07. What is the ratio of the Value added (current US$) of Estonia in 2001 to that in 2002?
Provide a short and direct response. 0.96. What is the ratio of the Value added (current US$) in Turkmenistan in 2001 to that in 2002?
Your answer should be compact. 0.87. What is the ratio of the Value added (current US$) of Benin in 2001 to that in 2003?
Your response must be concise. 0.69. What is the ratio of the Value added (current US$) in Burundi in 2001 to that in 2003?
Make the answer very short. 1.14. What is the ratio of the Value added (current US$) of Estonia in 2001 to that in 2003?
Your answer should be very brief. 0.75. What is the ratio of the Value added (current US$) of Turkmenistan in 2001 to that in 2003?
Make the answer very short. 0.71. What is the ratio of the Value added (current US$) in Benin in 2001 to that in 2004?
Provide a short and direct response. 0.55. What is the ratio of the Value added (current US$) of Estonia in 2001 to that in 2004?
Ensure brevity in your answer.  0.64. What is the ratio of the Value added (current US$) of Turkmenistan in 2001 to that in 2004?
Offer a very short reply. 0.65. What is the ratio of the Value added (current US$) of Benin in 2001 to that in 2005?
Offer a terse response. 0.52. What is the ratio of the Value added (current US$) in Burundi in 2001 to that in 2005?
Keep it short and to the point. 0.84. What is the ratio of the Value added (current US$) in Estonia in 2001 to that in 2005?
Offer a very short reply. 0.61. What is the ratio of the Value added (current US$) in Turkmenistan in 2001 to that in 2005?
Ensure brevity in your answer.  0.54. What is the ratio of the Value added (current US$) of Benin in 2001 to that in 2006?
Your response must be concise. 0.47. What is the ratio of the Value added (current US$) in Burundi in 2001 to that in 2006?
Make the answer very short. 0.74. What is the ratio of the Value added (current US$) of Estonia in 2001 to that in 2006?
Provide a succinct answer. 0.57. What is the ratio of the Value added (current US$) in Turkmenistan in 2001 to that in 2006?
Your response must be concise. 0.46. What is the ratio of the Value added (current US$) in Benin in 2001 to that in 2007?
Offer a terse response. 0.42. What is the ratio of the Value added (current US$) of Burundi in 2001 to that in 2007?
Keep it short and to the point. 0.83. What is the ratio of the Value added (current US$) in Estonia in 2001 to that in 2007?
Your response must be concise. 0.39. What is the ratio of the Value added (current US$) in Turkmenistan in 2001 to that in 2007?
Provide a succinct answer. 0.34. What is the ratio of the Value added (current US$) in Benin in 2001 to that in 2008?
Give a very brief answer. 0.36. What is the ratio of the Value added (current US$) of Burundi in 2001 to that in 2008?
Offer a terse response. 0.64. What is the ratio of the Value added (current US$) in Estonia in 2001 to that in 2008?
Offer a very short reply. 0.45. What is the ratio of the Value added (current US$) of Turkmenistan in 2001 to that in 2008?
Your answer should be very brief. 0.35. What is the ratio of the Value added (current US$) of Benin in 2002 to that in 2003?
Make the answer very short. 0.82. What is the ratio of the Value added (current US$) of Burundi in 2002 to that in 2003?
Offer a very short reply. 1.06. What is the ratio of the Value added (current US$) of Estonia in 2002 to that in 2003?
Provide a succinct answer. 0.78. What is the ratio of the Value added (current US$) in Turkmenistan in 2002 to that in 2003?
Keep it short and to the point. 0.82. What is the ratio of the Value added (current US$) in Benin in 2002 to that in 2004?
Your answer should be very brief. 0.65. What is the ratio of the Value added (current US$) in Burundi in 2002 to that in 2004?
Your answer should be very brief. 0.93. What is the ratio of the Value added (current US$) of Estonia in 2002 to that in 2004?
Provide a short and direct response. 0.66. What is the ratio of the Value added (current US$) of Turkmenistan in 2002 to that in 2004?
Your response must be concise. 0.74. What is the ratio of the Value added (current US$) of Benin in 2002 to that in 2005?
Your response must be concise. 0.61. What is the ratio of the Value added (current US$) in Burundi in 2002 to that in 2005?
Your response must be concise. 0.78. What is the ratio of the Value added (current US$) in Estonia in 2002 to that in 2005?
Your response must be concise. 0.64. What is the ratio of the Value added (current US$) of Turkmenistan in 2002 to that in 2005?
Make the answer very short. 0.62. What is the ratio of the Value added (current US$) of Benin in 2002 to that in 2006?
Your answer should be very brief. 0.56. What is the ratio of the Value added (current US$) in Burundi in 2002 to that in 2006?
Provide a short and direct response. 0.69. What is the ratio of the Value added (current US$) in Estonia in 2002 to that in 2006?
Your answer should be very brief. 0.6. What is the ratio of the Value added (current US$) in Turkmenistan in 2002 to that in 2006?
Your response must be concise. 0.53. What is the ratio of the Value added (current US$) in Benin in 2002 to that in 2007?
Your response must be concise. 0.5. What is the ratio of the Value added (current US$) of Burundi in 2002 to that in 2007?
Offer a terse response. 0.77. What is the ratio of the Value added (current US$) in Estonia in 2002 to that in 2007?
Provide a short and direct response. 0.41. What is the ratio of the Value added (current US$) of Turkmenistan in 2002 to that in 2007?
Provide a short and direct response. 0.39. What is the ratio of the Value added (current US$) of Benin in 2002 to that in 2008?
Your answer should be compact. 0.43. What is the ratio of the Value added (current US$) in Burundi in 2002 to that in 2008?
Your answer should be very brief. 0.6. What is the ratio of the Value added (current US$) of Estonia in 2002 to that in 2008?
Your response must be concise. 0.47. What is the ratio of the Value added (current US$) of Turkmenistan in 2002 to that in 2008?
Give a very brief answer. 0.4. What is the ratio of the Value added (current US$) in Benin in 2003 to that in 2004?
Provide a succinct answer. 0.8. What is the ratio of the Value added (current US$) of Burundi in 2003 to that in 2004?
Provide a succinct answer. 0.88. What is the ratio of the Value added (current US$) in Estonia in 2003 to that in 2004?
Ensure brevity in your answer.  0.85. What is the ratio of the Value added (current US$) in Turkmenistan in 2003 to that in 2004?
Give a very brief answer. 0.91. What is the ratio of the Value added (current US$) in Benin in 2003 to that in 2005?
Provide a succinct answer. 0.75. What is the ratio of the Value added (current US$) in Burundi in 2003 to that in 2005?
Provide a succinct answer. 0.74. What is the ratio of the Value added (current US$) of Estonia in 2003 to that in 2005?
Your response must be concise. 0.82. What is the ratio of the Value added (current US$) in Turkmenistan in 2003 to that in 2005?
Provide a short and direct response. 0.76. What is the ratio of the Value added (current US$) of Benin in 2003 to that in 2006?
Give a very brief answer. 0.69. What is the ratio of the Value added (current US$) of Burundi in 2003 to that in 2006?
Your answer should be very brief. 0.65. What is the ratio of the Value added (current US$) in Estonia in 2003 to that in 2006?
Ensure brevity in your answer.  0.77. What is the ratio of the Value added (current US$) in Turkmenistan in 2003 to that in 2006?
Your answer should be compact. 0.65. What is the ratio of the Value added (current US$) of Benin in 2003 to that in 2007?
Make the answer very short. 0.61. What is the ratio of the Value added (current US$) in Burundi in 2003 to that in 2007?
Your answer should be very brief. 0.72. What is the ratio of the Value added (current US$) in Estonia in 2003 to that in 2007?
Ensure brevity in your answer.  0.53. What is the ratio of the Value added (current US$) in Turkmenistan in 2003 to that in 2007?
Offer a terse response. 0.48. What is the ratio of the Value added (current US$) of Benin in 2003 to that in 2008?
Your answer should be very brief. 0.52. What is the ratio of the Value added (current US$) in Burundi in 2003 to that in 2008?
Offer a very short reply. 0.56. What is the ratio of the Value added (current US$) of Estonia in 2003 to that in 2008?
Make the answer very short. 0.6. What is the ratio of the Value added (current US$) in Turkmenistan in 2003 to that in 2008?
Provide a short and direct response. 0.49. What is the ratio of the Value added (current US$) in Benin in 2004 to that in 2005?
Keep it short and to the point. 0.94. What is the ratio of the Value added (current US$) of Burundi in 2004 to that in 2005?
Make the answer very short. 0.84. What is the ratio of the Value added (current US$) of Estonia in 2004 to that in 2005?
Make the answer very short. 0.96. What is the ratio of the Value added (current US$) of Turkmenistan in 2004 to that in 2005?
Offer a very short reply. 0.84. What is the ratio of the Value added (current US$) of Benin in 2004 to that in 2006?
Keep it short and to the point. 0.86. What is the ratio of the Value added (current US$) in Burundi in 2004 to that in 2006?
Offer a very short reply. 0.74. What is the ratio of the Value added (current US$) in Estonia in 2004 to that in 2006?
Your answer should be very brief. 0.9. What is the ratio of the Value added (current US$) of Turkmenistan in 2004 to that in 2006?
Provide a succinct answer. 0.71. What is the ratio of the Value added (current US$) in Benin in 2004 to that in 2007?
Your answer should be compact. 0.77. What is the ratio of the Value added (current US$) of Burundi in 2004 to that in 2007?
Ensure brevity in your answer.  0.82. What is the ratio of the Value added (current US$) of Estonia in 2004 to that in 2007?
Provide a short and direct response. 0.62. What is the ratio of the Value added (current US$) in Turkmenistan in 2004 to that in 2007?
Provide a succinct answer. 0.53. What is the ratio of the Value added (current US$) in Benin in 2004 to that in 2008?
Keep it short and to the point. 0.65. What is the ratio of the Value added (current US$) of Burundi in 2004 to that in 2008?
Provide a succinct answer. 0.64. What is the ratio of the Value added (current US$) of Estonia in 2004 to that in 2008?
Your response must be concise. 0.7. What is the ratio of the Value added (current US$) in Turkmenistan in 2004 to that in 2008?
Provide a succinct answer. 0.54. What is the ratio of the Value added (current US$) in Benin in 2005 to that in 2006?
Your answer should be compact. 0.91. What is the ratio of the Value added (current US$) in Burundi in 2005 to that in 2006?
Your answer should be very brief. 0.88. What is the ratio of the Value added (current US$) in Estonia in 2005 to that in 2006?
Offer a very short reply. 0.94. What is the ratio of the Value added (current US$) of Turkmenistan in 2005 to that in 2006?
Make the answer very short. 0.85. What is the ratio of the Value added (current US$) in Benin in 2005 to that in 2007?
Ensure brevity in your answer.  0.82. What is the ratio of the Value added (current US$) of Burundi in 2005 to that in 2007?
Keep it short and to the point. 0.98. What is the ratio of the Value added (current US$) of Estonia in 2005 to that in 2007?
Provide a succinct answer. 0.64. What is the ratio of the Value added (current US$) in Turkmenistan in 2005 to that in 2007?
Offer a very short reply. 0.63. What is the ratio of the Value added (current US$) in Benin in 2005 to that in 2008?
Offer a terse response. 0.69. What is the ratio of the Value added (current US$) of Burundi in 2005 to that in 2008?
Your answer should be very brief. 0.76. What is the ratio of the Value added (current US$) in Estonia in 2005 to that in 2008?
Provide a short and direct response. 0.73. What is the ratio of the Value added (current US$) of Turkmenistan in 2005 to that in 2008?
Make the answer very short. 0.64. What is the ratio of the Value added (current US$) of Benin in 2006 to that in 2007?
Provide a succinct answer. 0.9. What is the ratio of the Value added (current US$) in Burundi in 2006 to that in 2007?
Make the answer very short. 1.11. What is the ratio of the Value added (current US$) of Estonia in 2006 to that in 2007?
Provide a short and direct response. 0.68. What is the ratio of the Value added (current US$) in Turkmenistan in 2006 to that in 2007?
Keep it short and to the point. 0.74. What is the ratio of the Value added (current US$) in Benin in 2006 to that in 2008?
Offer a very short reply. 0.76. What is the ratio of the Value added (current US$) in Burundi in 2006 to that in 2008?
Your answer should be compact. 0.86. What is the ratio of the Value added (current US$) of Estonia in 2006 to that in 2008?
Ensure brevity in your answer.  0.78. What is the ratio of the Value added (current US$) in Turkmenistan in 2006 to that in 2008?
Offer a terse response. 0.76. What is the ratio of the Value added (current US$) in Benin in 2007 to that in 2008?
Ensure brevity in your answer.  0.85. What is the ratio of the Value added (current US$) of Burundi in 2007 to that in 2008?
Keep it short and to the point. 0.78. What is the ratio of the Value added (current US$) of Estonia in 2007 to that in 2008?
Provide a short and direct response. 1.14. What is the ratio of the Value added (current US$) in Turkmenistan in 2007 to that in 2008?
Give a very brief answer. 1.02. What is the difference between the highest and the second highest Value added (current US$) of Benin?
Make the answer very short. 2.61e+08. What is the difference between the highest and the second highest Value added (current US$) of Burundi?
Provide a succinct answer. 8.27e+07. What is the difference between the highest and the second highest Value added (current US$) in Estonia?
Your answer should be compact. 8.30e+07. What is the difference between the highest and the second highest Value added (current US$) of Turkmenistan?
Give a very brief answer. 5.48e+07. What is the difference between the highest and the lowest Value added (current US$) in Benin?
Provide a succinct answer. 1.09e+09. What is the difference between the highest and the lowest Value added (current US$) in Burundi?
Make the answer very short. 2.64e+08. What is the difference between the highest and the lowest Value added (current US$) in Estonia?
Your response must be concise. 4.10e+08. What is the difference between the highest and the lowest Value added (current US$) of Turkmenistan?
Ensure brevity in your answer.  1.57e+09. 